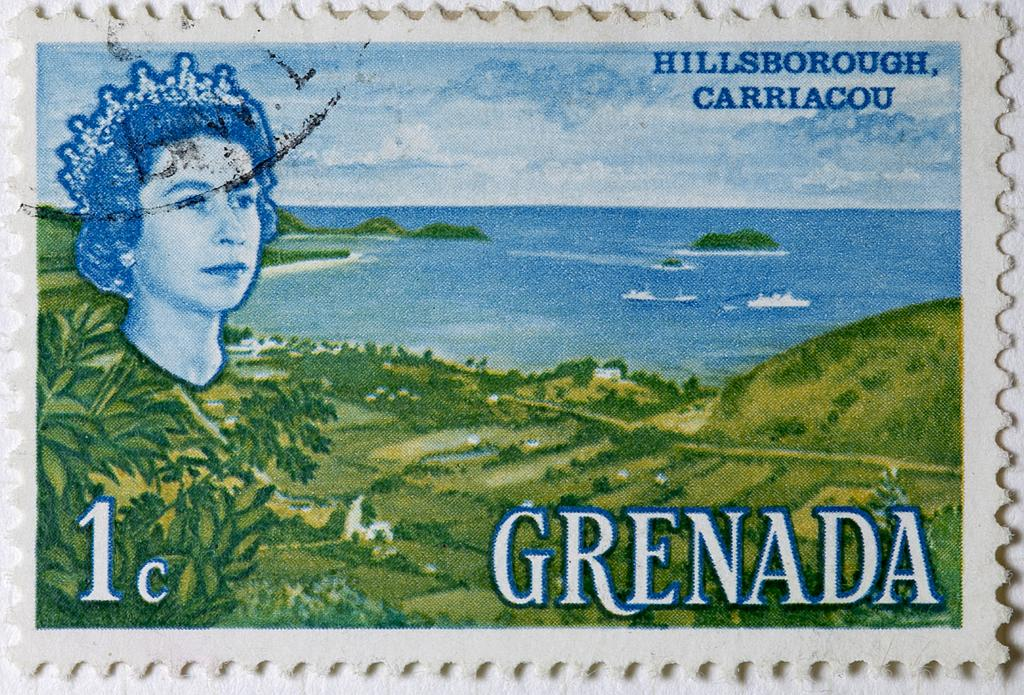What type of visual is the image? The image is a poster. Who or what is depicted in the poster? There is a woman in the poster. What natural elements are present in the poster? There are trees and boats on water in the poster. What can be seen in the sky in the poster? The sky with clouds is visible in the poster. Are there any words or phrases in the poster? Yes, there is text in the poster. Where is the volcano located in the poster? There is no volcano present in the poster. What is the plot of the story depicted in the poster? The image is a poster, not a story, so there is no plot to describe. 